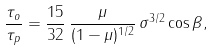<formula> <loc_0><loc_0><loc_500><loc_500>\frac { \tau _ { o } } { \tau _ { p } } = \frac { 1 5 } { 3 2 } \, \frac { \mu } { ( 1 - \mu ) ^ { 1 / 2 } } \, { \sigma ^ { 3 / 2 } \cos \beta } ,</formula> 